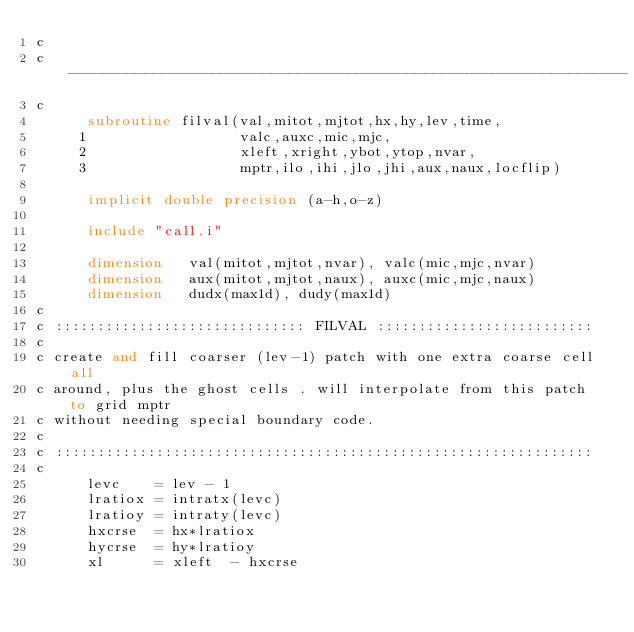Convert code to text. <code><loc_0><loc_0><loc_500><loc_500><_FORTRAN_>c
c ------------------------------------------------------------------
c
      subroutine filval(val,mitot,mjtot,hx,hy,lev,time,
     1                  valc,auxc,mic,mjc,
     2                  xleft,xright,ybot,ytop,nvar,
     3                  mptr,ilo,ihi,jlo,jhi,aux,naux,locflip)
 
      implicit double precision (a-h,o-z)

      include "call.i"

      dimension   val(mitot,mjtot,nvar), valc(mic,mjc,nvar)
      dimension   aux(mitot,mjtot,naux), auxc(mic,mjc,naux)
      dimension   dudx(max1d), dudy(max1d)
c
c :::::::::::::::::::::::::::::: FILVAL ::::::::::::::::::::::::::
c
c create and fill coarser (lev-1) patch with one extra coarse cell all
c around, plus the ghost cells . will interpolate from this patch to grid mptr 
c without needing special boundary code. 
c
c ::::::::::::::::::::::::::::::::::::::::::::::::::::::::::::::::
c
      levc    = lev - 1
      lratiox = intratx(levc)
      lratioy = intraty(levc)
      hxcrse  = hx*lratiox
      hycrse  = hy*lratioy
      xl      = xleft  - hxcrse </code> 